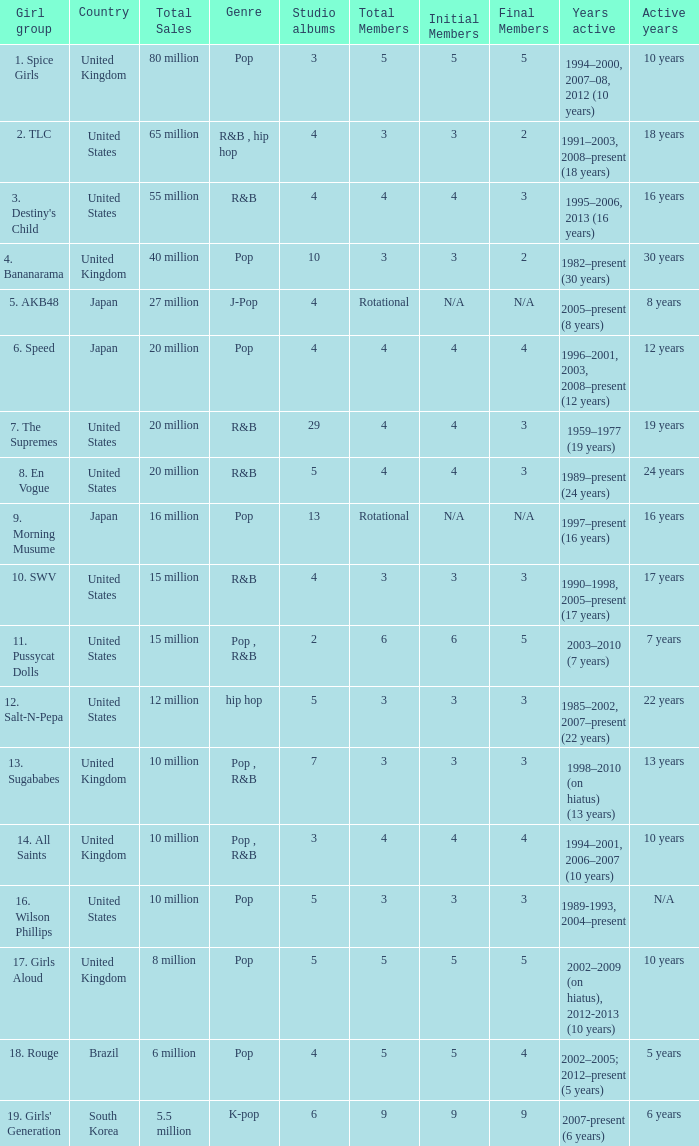How many members were in the group that sold 65 million albums and singles? 3 → 2. 